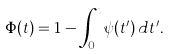Convert formula to latex. <formula><loc_0><loc_0><loc_500><loc_500>\Phi ( t ) = 1 - \int _ { 0 } ^ { t } \psi ( t ^ { \prime } ) \, d t ^ { \prime } .</formula> 